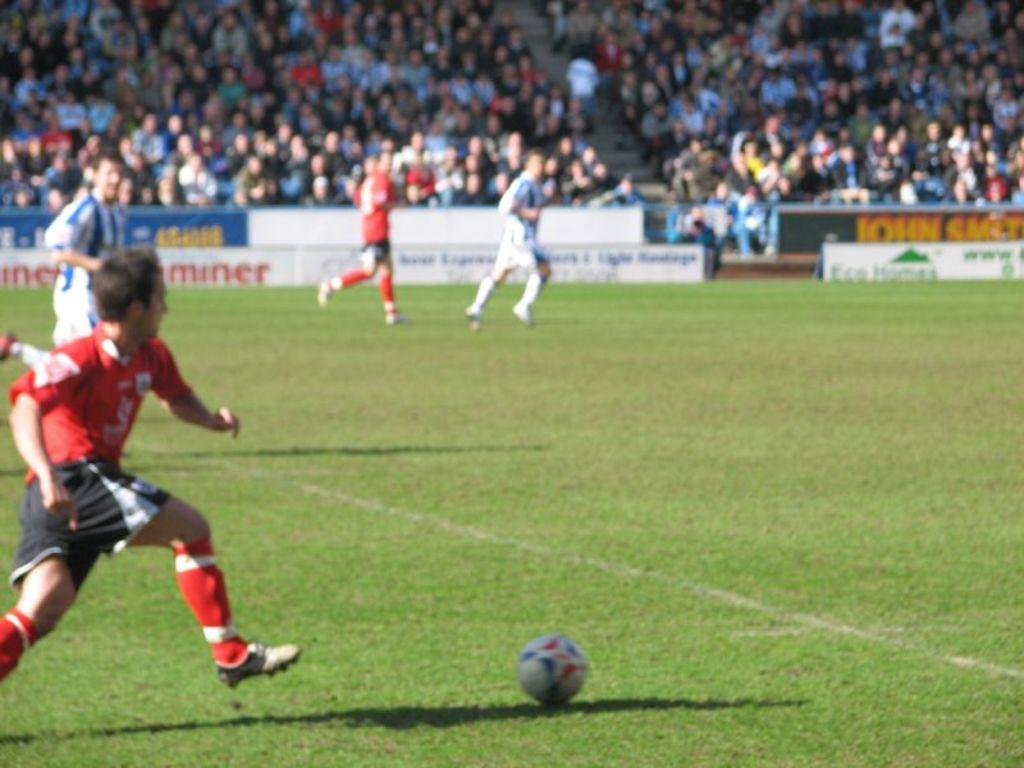Does it say miner in the back?
Your answer should be very brief. Yes. 